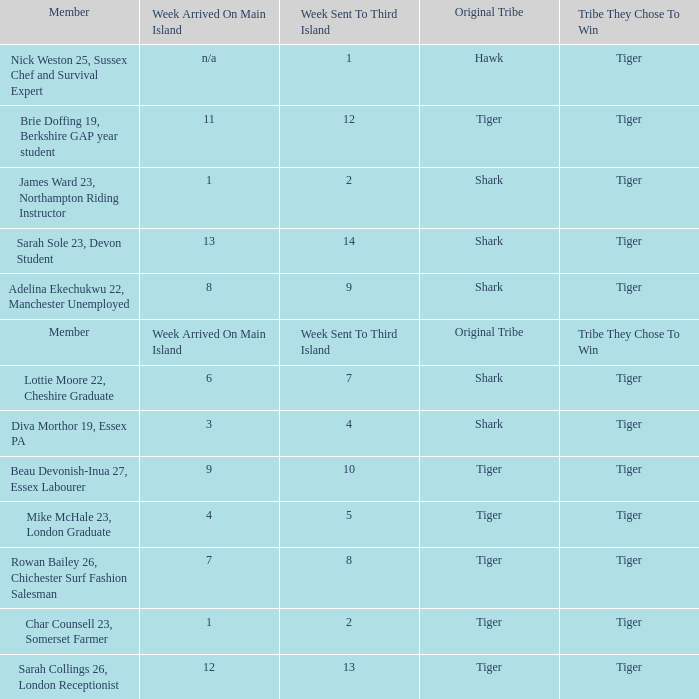What week was the member who arrived on the main island in week 6 sent to the third island? 7.0. 